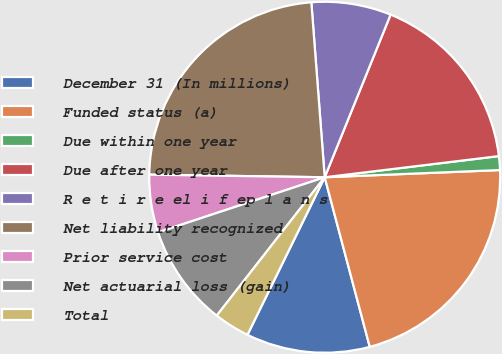Convert chart. <chart><loc_0><loc_0><loc_500><loc_500><pie_chart><fcel>December 31 (In millions)<fcel>Funded status (a)<fcel>Due within one year<fcel>Due after one year<fcel>R e t i r e el i f ep l a n s<fcel>Net liability recognized<fcel>Prior service cost<fcel>Net actuarial loss (gain)<fcel>Total<nl><fcel>11.39%<fcel>21.52%<fcel>1.27%<fcel>16.95%<fcel>7.34%<fcel>23.55%<fcel>5.32%<fcel>9.37%<fcel>3.29%<nl></chart> 